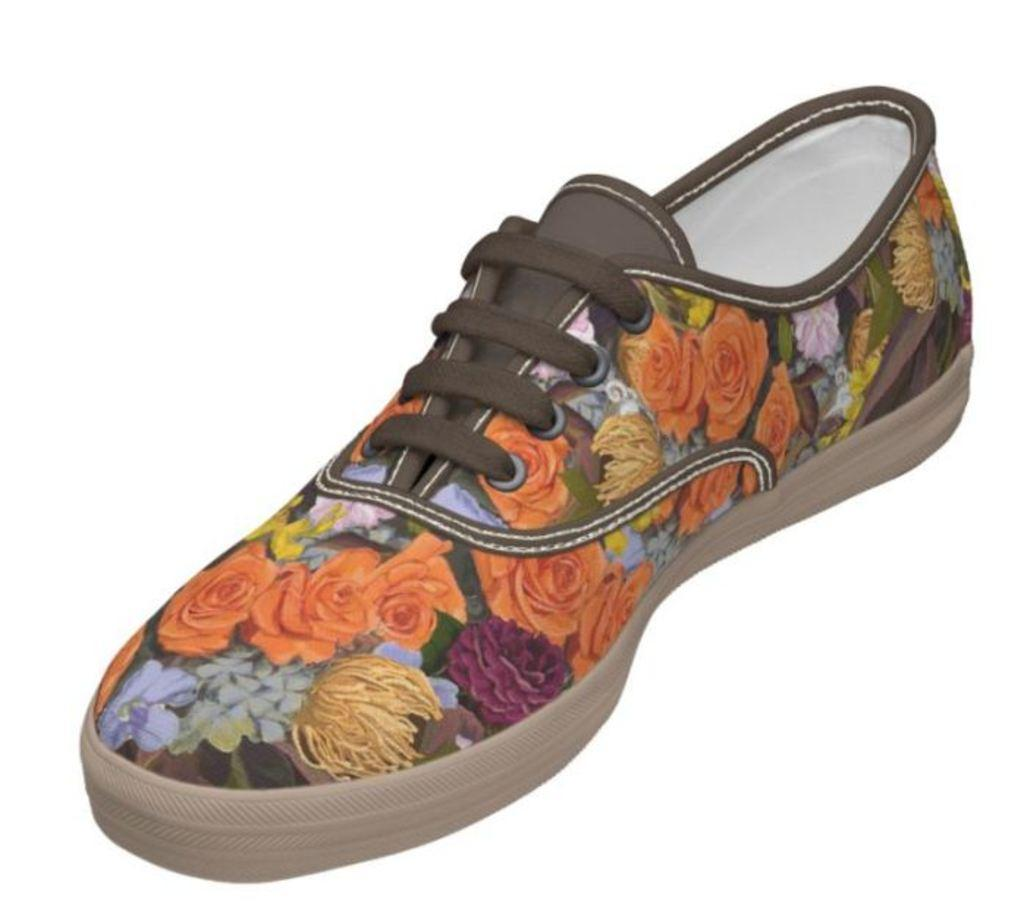What object is the main focus of the image? There is a shoe in the image. What design can be seen on the shoe? The shoe has a drawing of orange color flowers on it. How many turkeys are visible in the image? There are no turkeys present in the image; it features a shoe with a drawing of orange color flowers. What type of coil is used to create the design on the shoe? The image does not provide information about the method used to create the design on the shoe, so it cannot be determined from the image. 